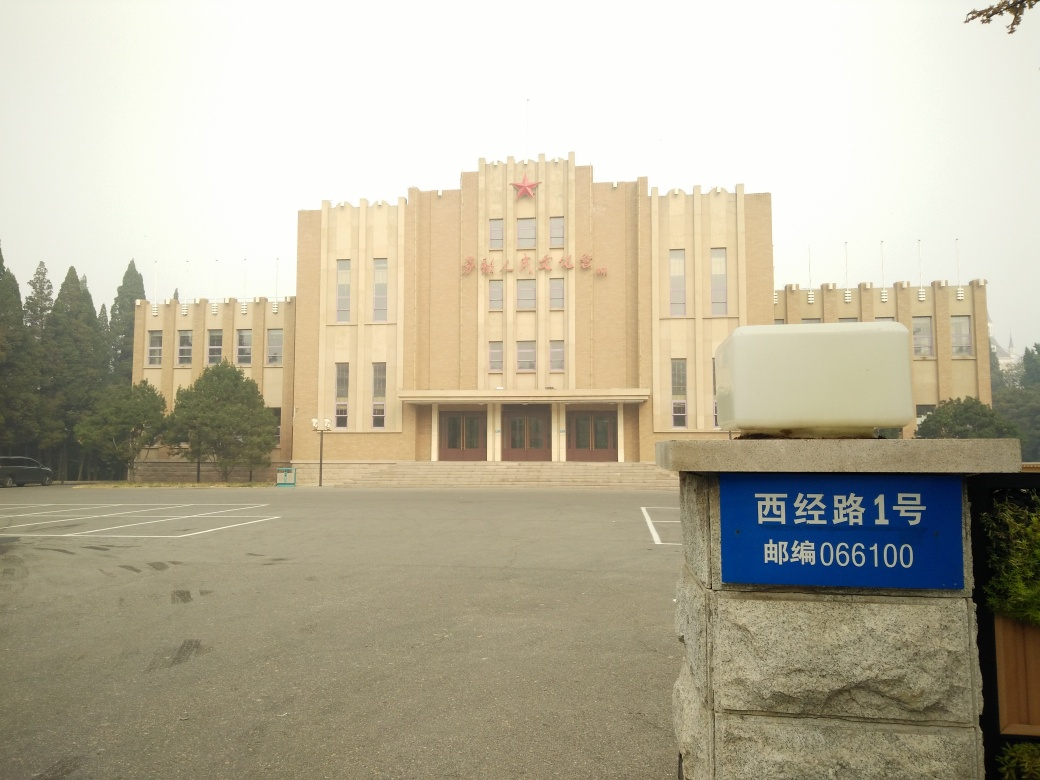What might the function of the building in the image be, based on its features and surroundings? Given the formal architecture, the size of the building, and the absence of commercial banners or signs, it is likely that the building serves a governmental or educational function, as these types of buildings often have a more stately design. Is there any indication of the location or specific setting for this image? The characters on the sign appear to be in Chinese, which suggests that the location is in a Chinese-speaking region. The parking lot setup and lack of heavy traffic hint at a suburban setting or a campus-like environment. 